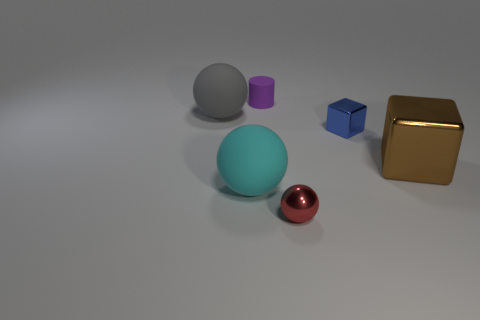Subtract all big rubber spheres. How many spheres are left? 1 Add 2 cubes. How many objects exist? 8 Subtract all cylinders. How many objects are left? 5 Subtract all brown blocks. Subtract all brown metallic blocks. How many objects are left? 4 Add 5 small red metal objects. How many small red metal objects are left? 6 Add 4 blue objects. How many blue objects exist? 5 Subtract 0 red cylinders. How many objects are left? 6 Subtract all purple balls. Subtract all brown blocks. How many balls are left? 3 